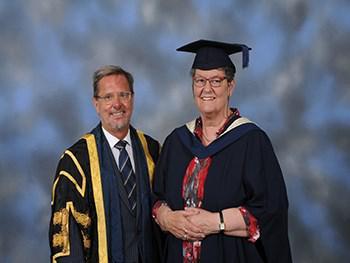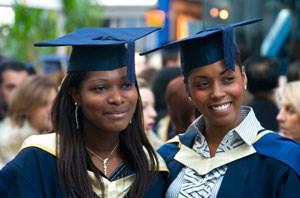The first image is the image on the left, the second image is the image on the right. Analyze the images presented: Is the assertion "The graduates in the right image are wearing blue gowns." valid? Answer yes or no. Yes. The first image is the image on the left, the second image is the image on the right. Evaluate the accuracy of this statement regarding the images: "One image shows two forward-facing dark-haired female graduates in the foreground, wearing matching hats and robes with a white V at the collar.". Is it true? Answer yes or no. Yes. 